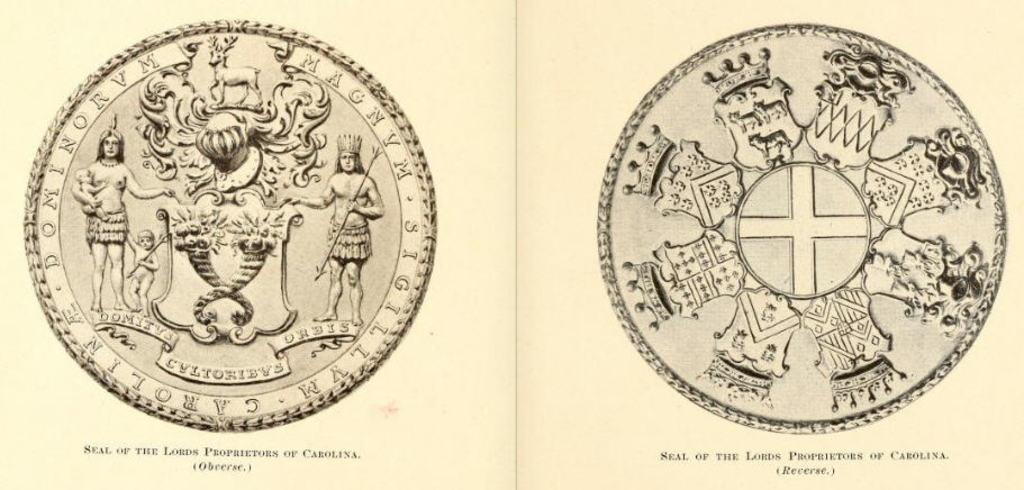<image>
Summarize the visual content of the image. Two coins are displayed that are labeled as seals of the lords proprietors of Carolina. 